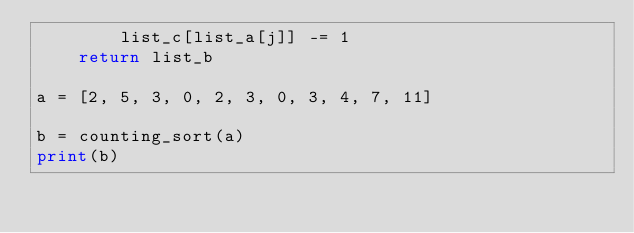<code> <loc_0><loc_0><loc_500><loc_500><_Python_>        list_c[list_a[j]] -= 1
    return list_b

a = [2, 5, 3, 0, 2, 3, 0, 3, 4, 7, 11]

b = counting_sort(a)
print(b)</code> 